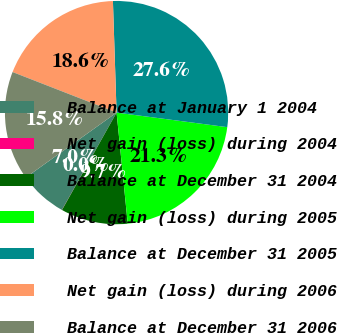<chart> <loc_0><loc_0><loc_500><loc_500><pie_chart><fcel>Balance at January 1 2004<fcel>Net gain (loss) during 2004<fcel>Balance at December 31 2004<fcel>Net gain (loss) during 2005<fcel>Balance at December 31 2005<fcel>Net gain (loss) during 2006<fcel>Balance at December 31 2006<nl><fcel>6.97%<fcel>0.02%<fcel>9.72%<fcel>21.32%<fcel>27.6%<fcel>18.56%<fcel>15.8%<nl></chart> 